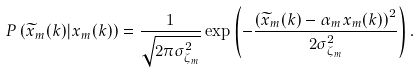<formula> <loc_0><loc_0><loc_500><loc_500>& P \left ( \widetilde { x } _ { m } ( k ) | { x } _ { m } ( k ) \right ) = \frac { 1 } { \sqrt { 2 \pi \sigma ^ { 2 } _ { \zeta _ { m } } } } \exp \left ( - \frac { \left ( \widetilde { x } _ { m } ( k ) - \alpha _ { m } { x } _ { m } ( k ) \right ) ^ { 2 } } { 2 \sigma ^ { 2 } _ { \zeta _ { m } } } \right ) .</formula> 